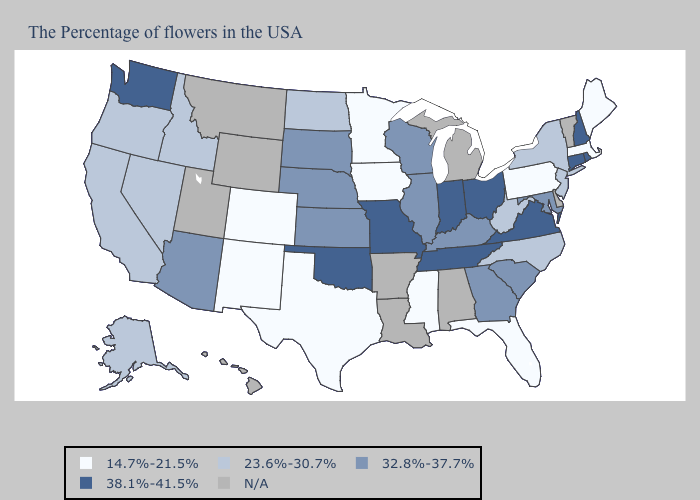What is the value of Oregon?
Keep it brief. 23.6%-30.7%. Does Washington have the highest value in the West?
Concise answer only. Yes. Name the states that have a value in the range 38.1%-41.5%?
Be succinct. Rhode Island, New Hampshire, Connecticut, Virginia, Ohio, Indiana, Tennessee, Missouri, Oklahoma, Washington. Does the first symbol in the legend represent the smallest category?
Short answer required. Yes. Among the states that border Colorado , which have the highest value?
Answer briefly. Oklahoma. What is the value of Florida?
Give a very brief answer. 14.7%-21.5%. What is the lowest value in the Northeast?
Quick response, please. 14.7%-21.5%. Name the states that have a value in the range 32.8%-37.7%?
Write a very short answer. Maryland, South Carolina, Georgia, Kentucky, Wisconsin, Illinois, Kansas, Nebraska, South Dakota, Arizona. Name the states that have a value in the range N/A?
Keep it brief. Vermont, Delaware, Michigan, Alabama, Louisiana, Arkansas, Wyoming, Utah, Montana, Hawaii. Among the states that border New Hampshire , which have the lowest value?
Concise answer only. Maine, Massachusetts. Among the states that border Massachusetts , which have the highest value?
Be succinct. Rhode Island, New Hampshire, Connecticut. What is the value of Georgia?
Concise answer only. 32.8%-37.7%. Which states have the highest value in the USA?
Be succinct. Rhode Island, New Hampshire, Connecticut, Virginia, Ohio, Indiana, Tennessee, Missouri, Oklahoma, Washington. What is the value of South Carolina?
Concise answer only. 32.8%-37.7%. 